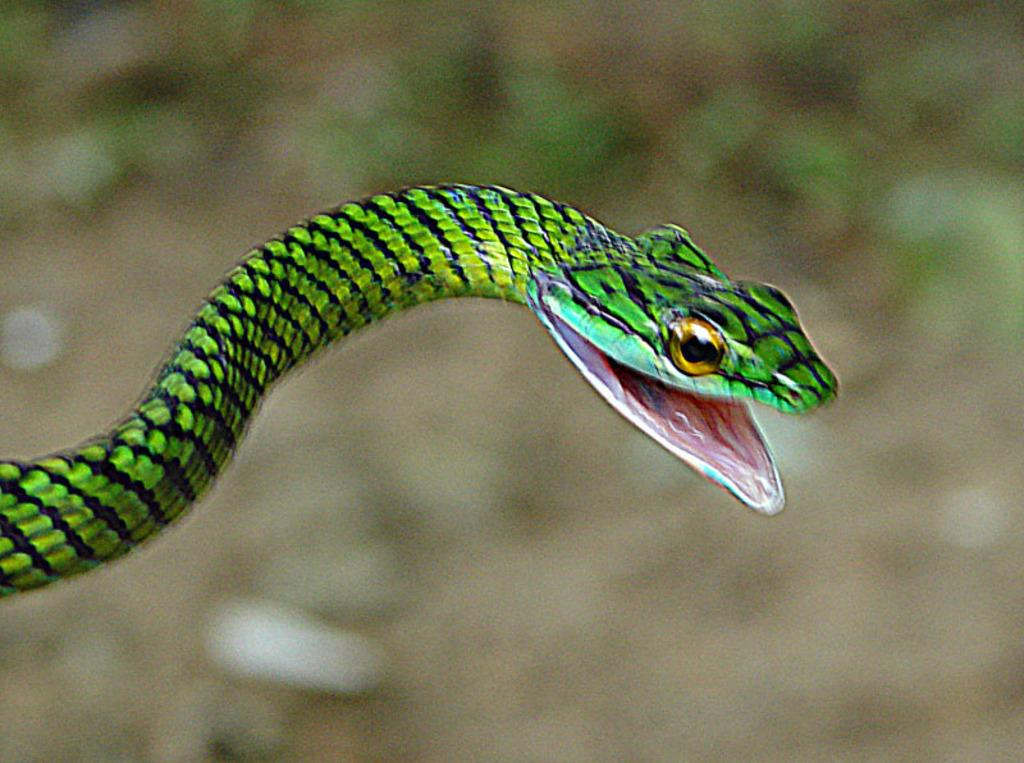What animal is present in the image? There is a snake in the image. What colors can be seen on the snake? The snake is black and green in color. Can you describe the background of the image? The background of the image is blurred. What type of apparatus is being used by the snake in the image? There is no apparatus present in the image; it features a snake with no additional objects or tools. 